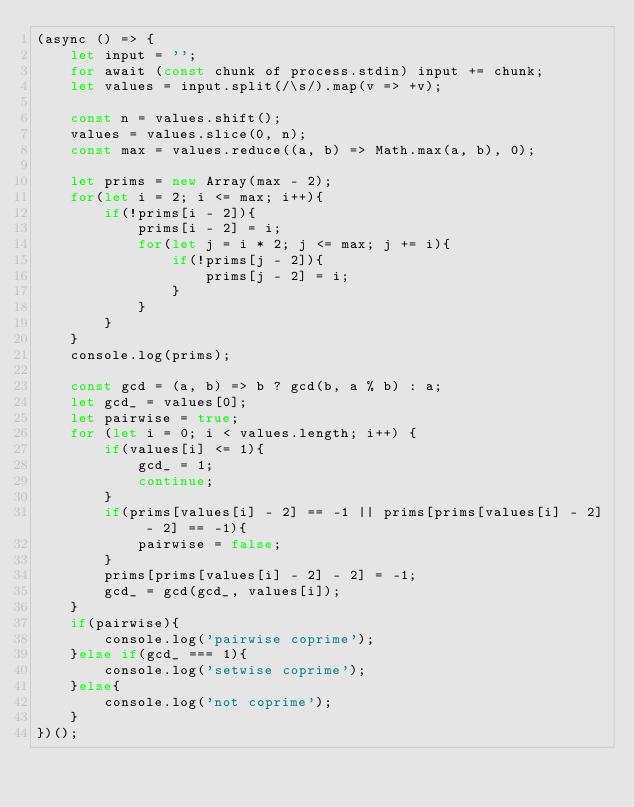<code> <loc_0><loc_0><loc_500><loc_500><_JavaScript_>(async () => {
    let input = '';
    for await (const chunk of process.stdin) input += chunk;
    let values = input.split(/\s/).map(v => +v);

    const n = values.shift();
    values = values.slice(0, n);
    const max = values.reduce((a, b) => Math.max(a, b), 0);

    let prims = new Array(max - 2);
    for(let i = 2; i <= max; i++){
        if(!prims[i - 2]){
            prims[i - 2] = i;
            for(let j = i * 2; j <= max; j += i){
                if(!prims[j - 2]){
                    prims[j - 2] = i;
                }
            }
        }
    }
    console.log(prims);

    const gcd = (a, b) => b ? gcd(b, a % b) : a;
    let gcd_ = values[0];
    let pairwise = true;
    for (let i = 0; i < values.length; i++) {
        if(values[i] <= 1){
            gcd_ = 1;
            continue;
        }
        if(prims[values[i] - 2] == -1 || prims[prims[values[i] - 2] - 2] == -1){
            pairwise = false;
        }
        prims[prims[values[i] - 2] - 2] = -1;
        gcd_ = gcd(gcd_, values[i]);
    }
    if(pairwise){
        console.log('pairwise coprime');
    }else if(gcd_ === 1){
        console.log('setwise coprime');
    }else{
        console.log('not coprime');
    }
})();
</code> 